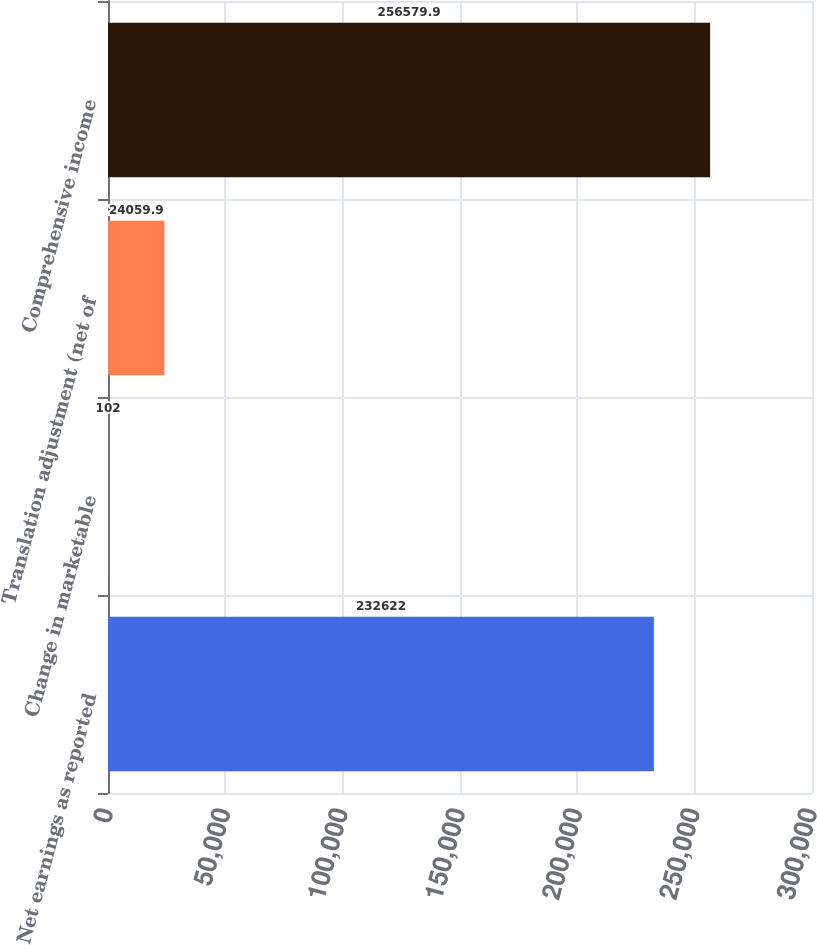<chart> <loc_0><loc_0><loc_500><loc_500><bar_chart><fcel>Net earnings as reported<fcel>Change in marketable<fcel>Translation adjustment (net of<fcel>Comprehensive income<nl><fcel>232622<fcel>102<fcel>24059.9<fcel>256580<nl></chart> 